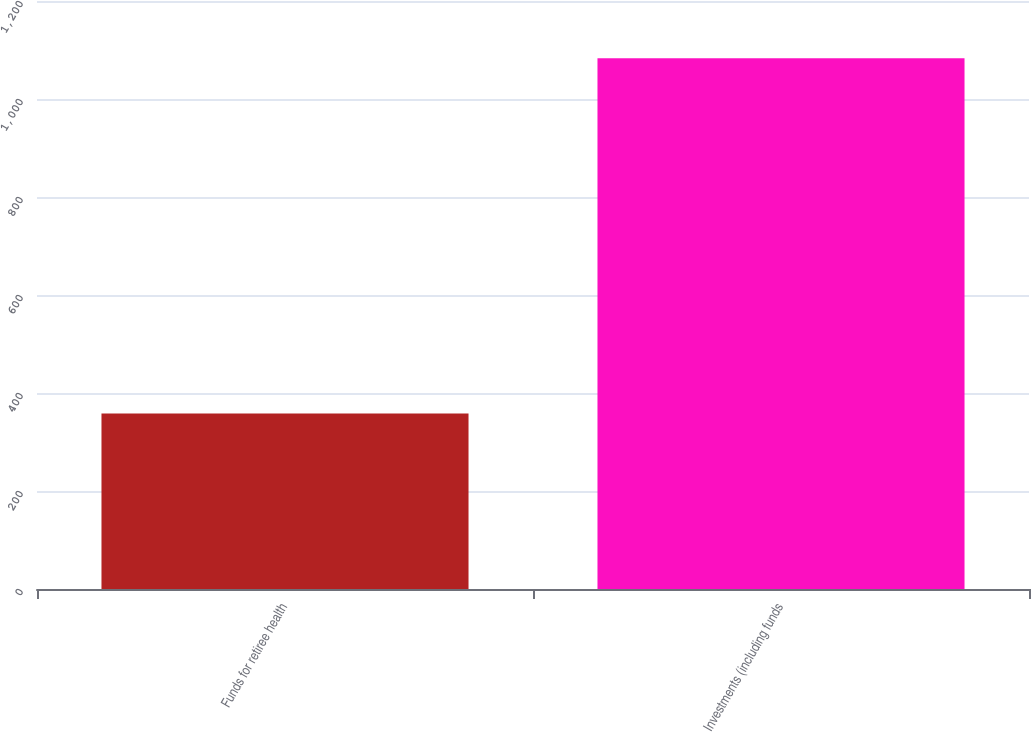<chart> <loc_0><loc_0><loc_500><loc_500><bar_chart><fcel>Funds for retiree health<fcel>Investments (including funds<nl><fcel>358<fcel>1083<nl></chart> 